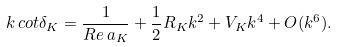Convert formula to latex. <formula><loc_0><loc_0><loc_500><loc_500>k \, c o t \delta _ { K } = \frac { 1 } { R e \, a _ { K } } + \frac { 1 } { 2 } R _ { K } k ^ { 2 } + V _ { K } k ^ { 4 } + O ( k ^ { 6 } ) .</formula> 